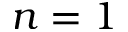<formula> <loc_0><loc_0><loc_500><loc_500>n = 1</formula> 